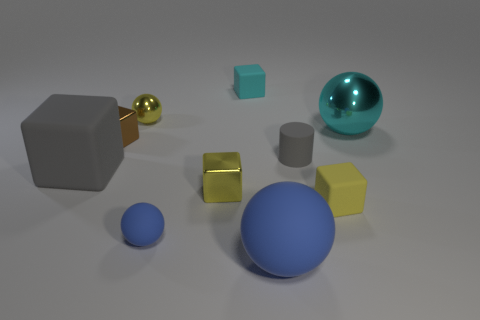What shape is the object that is the same color as the big rubber cube?
Your response must be concise. Cylinder. What number of other objects are the same material as the big blue sphere?
Your answer should be very brief. 5. Is the size of the cyan shiny sphere the same as the brown object?
Make the answer very short. No. There is a gray object that is behind the large block; what is its shape?
Your answer should be very brief. Cylinder. What is the color of the large matte thing right of the tiny block that is behind the tiny brown shiny thing?
Provide a succinct answer. Blue. There is a small yellow object that is behind the tiny gray rubber cylinder; is it the same shape as the large rubber thing that is to the right of the yellow shiny sphere?
Your answer should be compact. Yes. There is a gray matte thing that is the same size as the brown thing; what shape is it?
Offer a very short reply. Cylinder. What color is the other large sphere that is made of the same material as the yellow ball?
Your answer should be very brief. Cyan. There is a small cyan object; is its shape the same as the small yellow shiny object that is behind the gray block?
Give a very brief answer. No. There is a tiny thing that is the same color as the big metallic ball; what is it made of?
Your answer should be compact. Rubber. 